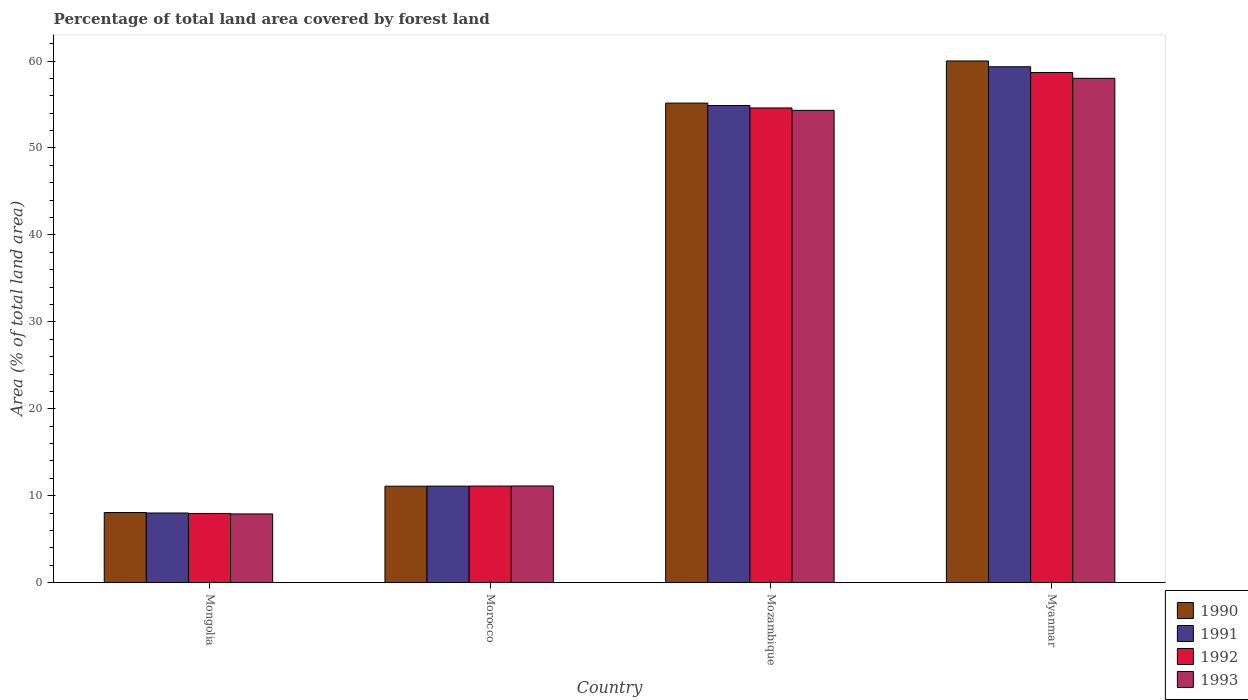How many groups of bars are there?
Offer a very short reply. 4. Are the number of bars on each tick of the X-axis equal?
Provide a succinct answer. Yes. How many bars are there on the 2nd tick from the left?
Provide a succinct answer. 4. What is the label of the 4th group of bars from the left?
Offer a terse response. Myanmar. In how many cases, is the number of bars for a given country not equal to the number of legend labels?
Ensure brevity in your answer.  0. What is the percentage of forest land in 1992 in Mongolia?
Your response must be concise. 7.96. Across all countries, what is the maximum percentage of forest land in 1990?
Keep it short and to the point. 60.01. Across all countries, what is the minimum percentage of forest land in 1993?
Offer a terse response. 7.91. In which country was the percentage of forest land in 1991 maximum?
Offer a very short reply. Myanmar. In which country was the percentage of forest land in 1991 minimum?
Make the answer very short. Mongolia. What is the total percentage of forest land in 1992 in the graph?
Your response must be concise. 132.36. What is the difference between the percentage of forest land in 1992 in Mozambique and that in Myanmar?
Offer a very short reply. -4.07. What is the difference between the percentage of forest land in 1993 in Mongolia and the percentage of forest land in 1990 in Mozambique?
Your response must be concise. -47.25. What is the average percentage of forest land in 1992 per country?
Your answer should be compact. 33.09. What is the difference between the percentage of forest land of/in 1990 and percentage of forest land of/in 1991 in Mongolia?
Provide a succinct answer. 0.05. In how many countries, is the percentage of forest land in 1990 greater than 34 %?
Offer a very short reply. 2. What is the ratio of the percentage of forest land in 1990 in Morocco to that in Mozambique?
Keep it short and to the point. 0.2. What is the difference between the highest and the second highest percentage of forest land in 1991?
Your response must be concise. -48.23. What is the difference between the highest and the lowest percentage of forest land in 1991?
Provide a succinct answer. 51.33. Is the sum of the percentage of forest land in 1991 in Mozambique and Myanmar greater than the maximum percentage of forest land in 1992 across all countries?
Keep it short and to the point. Yes. Is it the case that in every country, the sum of the percentage of forest land in 1992 and percentage of forest land in 1993 is greater than the sum of percentage of forest land in 1990 and percentage of forest land in 1991?
Ensure brevity in your answer.  No. What does the 1st bar from the left in Morocco represents?
Offer a terse response. 1990. What does the 3rd bar from the right in Morocco represents?
Ensure brevity in your answer.  1991. Are all the bars in the graph horizontal?
Make the answer very short. No. How many countries are there in the graph?
Provide a succinct answer. 4. What is the difference between two consecutive major ticks on the Y-axis?
Offer a very short reply. 10. Does the graph contain grids?
Ensure brevity in your answer.  No. What is the title of the graph?
Provide a short and direct response. Percentage of total land area covered by forest land. Does "1980" appear as one of the legend labels in the graph?
Your answer should be compact. No. What is the label or title of the X-axis?
Provide a short and direct response. Country. What is the label or title of the Y-axis?
Offer a very short reply. Area (% of total land area). What is the Area (% of total land area) in 1990 in Mongolia?
Give a very brief answer. 8.07. What is the Area (% of total land area) in 1991 in Mongolia?
Your answer should be compact. 8.02. What is the Area (% of total land area) of 1992 in Mongolia?
Offer a terse response. 7.96. What is the Area (% of total land area) in 1993 in Mongolia?
Provide a short and direct response. 7.91. What is the Area (% of total land area) in 1990 in Morocco?
Provide a short and direct response. 11.1. What is the Area (% of total land area) of 1991 in Morocco?
Offer a very short reply. 11.11. What is the Area (% of total land area) in 1992 in Morocco?
Offer a terse response. 11.12. What is the Area (% of total land area) of 1993 in Morocco?
Offer a terse response. 11.13. What is the Area (% of total land area) of 1990 in Mozambique?
Give a very brief answer. 55.16. What is the Area (% of total land area) in 1991 in Mozambique?
Offer a very short reply. 54.88. What is the Area (% of total land area) of 1992 in Mozambique?
Keep it short and to the point. 54.6. What is the Area (% of total land area) in 1993 in Mozambique?
Keep it short and to the point. 54.33. What is the Area (% of total land area) of 1990 in Myanmar?
Offer a terse response. 60.01. What is the Area (% of total land area) of 1991 in Myanmar?
Keep it short and to the point. 59.34. What is the Area (% of total land area) of 1992 in Myanmar?
Provide a short and direct response. 58.68. What is the Area (% of total land area) in 1993 in Myanmar?
Ensure brevity in your answer.  58.01. Across all countries, what is the maximum Area (% of total land area) in 1990?
Ensure brevity in your answer.  60.01. Across all countries, what is the maximum Area (% of total land area) in 1991?
Offer a terse response. 59.34. Across all countries, what is the maximum Area (% of total land area) of 1992?
Provide a succinct answer. 58.68. Across all countries, what is the maximum Area (% of total land area) of 1993?
Provide a short and direct response. 58.01. Across all countries, what is the minimum Area (% of total land area) in 1990?
Give a very brief answer. 8.07. Across all countries, what is the minimum Area (% of total land area) of 1991?
Give a very brief answer. 8.02. Across all countries, what is the minimum Area (% of total land area) of 1992?
Your response must be concise. 7.96. Across all countries, what is the minimum Area (% of total land area) of 1993?
Your response must be concise. 7.91. What is the total Area (% of total land area) in 1990 in the graph?
Provide a short and direct response. 134.34. What is the total Area (% of total land area) of 1991 in the graph?
Your answer should be compact. 133.35. What is the total Area (% of total land area) of 1992 in the graph?
Ensure brevity in your answer.  132.36. What is the total Area (% of total land area) of 1993 in the graph?
Your answer should be compact. 131.38. What is the difference between the Area (% of total land area) in 1990 in Mongolia and that in Morocco?
Offer a terse response. -3.03. What is the difference between the Area (% of total land area) of 1991 in Mongolia and that in Morocco?
Provide a succinct answer. -3.09. What is the difference between the Area (% of total land area) of 1992 in Mongolia and that in Morocco?
Offer a very short reply. -3.15. What is the difference between the Area (% of total land area) in 1993 in Mongolia and that in Morocco?
Offer a terse response. -3.22. What is the difference between the Area (% of total land area) in 1990 in Mongolia and that in Mozambique?
Keep it short and to the point. -47.09. What is the difference between the Area (% of total land area) of 1991 in Mongolia and that in Mozambique?
Your answer should be very brief. -46.87. What is the difference between the Area (% of total land area) in 1992 in Mongolia and that in Mozambique?
Offer a very short reply. -46.64. What is the difference between the Area (% of total land area) of 1993 in Mongolia and that in Mozambique?
Give a very brief answer. -46.42. What is the difference between the Area (% of total land area) of 1990 in Mongolia and that in Myanmar?
Your response must be concise. -51.94. What is the difference between the Area (% of total land area) in 1991 in Mongolia and that in Myanmar?
Your answer should be very brief. -51.33. What is the difference between the Area (% of total land area) in 1992 in Mongolia and that in Myanmar?
Keep it short and to the point. -50.71. What is the difference between the Area (% of total land area) in 1993 in Mongolia and that in Myanmar?
Your response must be concise. -50.1. What is the difference between the Area (% of total land area) in 1990 in Morocco and that in Mozambique?
Your answer should be very brief. -44.06. What is the difference between the Area (% of total land area) of 1991 in Morocco and that in Mozambique?
Provide a succinct answer. -43.77. What is the difference between the Area (% of total land area) of 1992 in Morocco and that in Mozambique?
Keep it short and to the point. -43.49. What is the difference between the Area (% of total land area) in 1993 in Morocco and that in Mozambique?
Provide a short and direct response. -43.2. What is the difference between the Area (% of total land area) of 1990 in Morocco and that in Myanmar?
Offer a terse response. -48.91. What is the difference between the Area (% of total land area) of 1991 in Morocco and that in Myanmar?
Keep it short and to the point. -48.23. What is the difference between the Area (% of total land area) of 1992 in Morocco and that in Myanmar?
Your response must be concise. -47.56. What is the difference between the Area (% of total land area) of 1993 in Morocco and that in Myanmar?
Ensure brevity in your answer.  -46.89. What is the difference between the Area (% of total land area) in 1990 in Mozambique and that in Myanmar?
Make the answer very short. -4.85. What is the difference between the Area (% of total land area) of 1991 in Mozambique and that in Myanmar?
Provide a succinct answer. -4.46. What is the difference between the Area (% of total land area) of 1992 in Mozambique and that in Myanmar?
Give a very brief answer. -4.07. What is the difference between the Area (% of total land area) in 1993 in Mozambique and that in Myanmar?
Ensure brevity in your answer.  -3.69. What is the difference between the Area (% of total land area) in 1990 in Mongolia and the Area (% of total land area) in 1991 in Morocco?
Provide a short and direct response. -3.04. What is the difference between the Area (% of total land area) in 1990 in Mongolia and the Area (% of total land area) in 1992 in Morocco?
Your response must be concise. -3.05. What is the difference between the Area (% of total land area) in 1990 in Mongolia and the Area (% of total land area) in 1993 in Morocco?
Provide a succinct answer. -3.06. What is the difference between the Area (% of total land area) of 1991 in Mongolia and the Area (% of total land area) of 1992 in Morocco?
Provide a short and direct response. -3.1. What is the difference between the Area (% of total land area) in 1991 in Mongolia and the Area (% of total land area) in 1993 in Morocco?
Offer a very short reply. -3.11. What is the difference between the Area (% of total land area) in 1992 in Mongolia and the Area (% of total land area) in 1993 in Morocco?
Your answer should be very brief. -3.16. What is the difference between the Area (% of total land area) in 1990 in Mongolia and the Area (% of total land area) in 1991 in Mozambique?
Make the answer very short. -46.81. What is the difference between the Area (% of total land area) in 1990 in Mongolia and the Area (% of total land area) in 1992 in Mozambique?
Give a very brief answer. -46.54. What is the difference between the Area (% of total land area) of 1990 in Mongolia and the Area (% of total land area) of 1993 in Mozambique?
Give a very brief answer. -46.26. What is the difference between the Area (% of total land area) of 1991 in Mongolia and the Area (% of total land area) of 1992 in Mozambique?
Offer a terse response. -46.59. What is the difference between the Area (% of total land area) of 1991 in Mongolia and the Area (% of total land area) of 1993 in Mozambique?
Your answer should be very brief. -46.31. What is the difference between the Area (% of total land area) of 1992 in Mongolia and the Area (% of total land area) of 1993 in Mozambique?
Ensure brevity in your answer.  -46.36. What is the difference between the Area (% of total land area) in 1990 in Mongolia and the Area (% of total land area) in 1991 in Myanmar?
Provide a short and direct response. -51.27. What is the difference between the Area (% of total land area) of 1990 in Mongolia and the Area (% of total land area) of 1992 in Myanmar?
Your response must be concise. -50.61. What is the difference between the Area (% of total land area) of 1990 in Mongolia and the Area (% of total land area) of 1993 in Myanmar?
Your answer should be very brief. -49.94. What is the difference between the Area (% of total land area) in 1991 in Mongolia and the Area (% of total land area) in 1992 in Myanmar?
Your answer should be compact. -50.66. What is the difference between the Area (% of total land area) of 1991 in Mongolia and the Area (% of total land area) of 1993 in Myanmar?
Provide a short and direct response. -50. What is the difference between the Area (% of total land area) of 1992 in Mongolia and the Area (% of total land area) of 1993 in Myanmar?
Your answer should be very brief. -50.05. What is the difference between the Area (% of total land area) of 1990 in Morocco and the Area (% of total land area) of 1991 in Mozambique?
Ensure brevity in your answer.  -43.78. What is the difference between the Area (% of total land area) of 1990 in Morocco and the Area (% of total land area) of 1992 in Mozambique?
Offer a very short reply. -43.5. What is the difference between the Area (% of total land area) of 1990 in Morocco and the Area (% of total land area) of 1993 in Mozambique?
Your answer should be very brief. -43.23. What is the difference between the Area (% of total land area) in 1991 in Morocco and the Area (% of total land area) in 1992 in Mozambique?
Your response must be concise. -43.5. What is the difference between the Area (% of total land area) of 1991 in Morocco and the Area (% of total land area) of 1993 in Mozambique?
Make the answer very short. -43.22. What is the difference between the Area (% of total land area) of 1992 in Morocco and the Area (% of total land area) of 1993 in Mozambique?
Keep it short and to the point. -43.21. What is the difference between the Area (% of total land area) in 1990 in Morocco and the Area (% of total land area) in 1991 in Myanmar?
Make the answer very short. -48.24. What is the difference between the Area (% of total land area) in 1990 in Morocco and the Area (% of total land area) in 1992 in Myanmar?
Offer a very short reply. -47.58. What is the difference between the Area (% of total land area) of 1990 in Morocco and the Area (% of total land area) of 1993 in Myanmar?
Offer a terse response. -46.91. What is the difference between the Area (% of total land area) in 1991 in Morocco and the Area (% of total land area) in 1992 in Myanmar?
Keep it short and to the point. -47.57. What is the difference between the Area (% of total land area) of 1991 in Morocco and the Area (% of total land area) of 1993 in Myanmar?
Make the answer very short. -46.9. What is the difference between the Area (% of total land area) of 1992 in Morocco and the Area (% of total land area) of 1993 in Myanmar?
Your answer should be very brief. -46.89. What is the difference between the Area (% of total land area) in 1990 in Mozambique and the Area (% of total land area) in 1991 in Myanmar?
Make the answer very short. -4.18. What is the difference between the Area (% of total land area) of 1990 in Mozambique and the Area (% of total land area) of 1992 in Myanmar?
Provide a succinct answer. -3.52. What is the difference between the Area (% of total land area) in 1990 in Mozambique and the Area (% of total land area) in 1993 in Myanmar?
Give a very brief answer. -2.85. What is the difference between the Area (% of total land area) of 1991 in Mozambique and the Area (% of total land area) of 1992 in Myanmar?
Offer a terse response. -3.79. What is the difference between the Area (% of total land area) in 1991 in Mozambique and the Area (% of total land area) in 1993 in Myanmar?
Provide a succinct answer. -3.13. What is the difference between the Area (% of total land area) in 1992 in Mozambique and the Area (% of total land area) in 1993 in Myanmar?
Ensure brevity in your answer.  -3.41. What is the average Area (% of total land area) in 1990 per country?
Provide a short and direct response. 33.58. What is the average Area (% of total land area) of 1991 per country?
Provide a succinct answer. 33.34. What is the average Area (% of total land area) in 1992 per country?
Your answer should be compact. 33.09. What is the average Area (% of total land area) in 1993 per country?
Your answer should be compact. 32.84. What is the difference between the Area (% of total land area) in 1990 and Area (% of total land area) in 1991 in Mongolia?
Offer a terse response. 0.05. What is the difference between the Area (% of total land area) in 1990 and Area (% of total land area) in 1992 in Mongolia?
Keep it short and to the point. 0.11. What is the difference between the Area (% of total land area) of 1990 and Area (% of total land area) of 1993 in Mongolia?
Provide a succinct answer. 0.16. What is the difference between the Area (% of total land area) of 1991 and Area (% of total land area) of 1992 in Mongolia?
Ensure brevity in your answer.  0.05. What is the difference between the Area (% of total land area) of 1991 and Area (% of total land area) of 1993 in Mongolia?
Offer a very short reply. 0.11. What is the difference between the Area (% of total land area) of 1992 and Area (% of total land area) of 1993 in Mongolia?
Your answer should be very brief. 0.05. What is the difference between the Area (% of total land area) of 1990 and Area (% of total land area) of 1991 in Morocco?
Make the answer very short. -0.01. What is the difference between the Area (% of total land area) in 1990 and Area (% of total land area) in 1992 in Morocco?
Make the answer very short. -0.02. What is the difference between the Area (% of total land area) of 1990 and Area (% of total land area) of 1993 in Morocco?
Give a very brief answer. -0.03. What is the difference between the Area (% of total land area) in 1991 and Area (% of total land area) in 1992 in Morocco?
Your answer should be very brief. -0.01. What is the difference between the Area (% of total land area) of 1991 and Area (% of total land area) of 1993 in Morocco?
Make the answer very short. -0.02. What is the difference between the Area (% of total land area) in 1992 and Area (% of total land area) in 1993 in Morocco?
Your response must be concise. -0.01. What is the difference between the Area (% of total land area) in 1990 and Area (% of total land area) in 1991 in Mozambique?
Provide a succinct answer. 0.28. What is the difference between the Area (% of total land area) in 1990 and Area (% of total land area) in 1992 in Mozambique?
Provide a short and direct response. 0.56. What is the difference between the Area (% of total land area) in 1990 and Area (% of total land area) in 1993 in Mozambique?
Your response must be concise. 0.84. What is the difference between the Area (% of total land area) in 1991 and Area (% of total land area) in 1992 in Mozambique?
Offer a very short reply. 0.28. What is the difference between the Area (% of total land area) of 1991 and Area (% of total land area) of 1993 in Mozambique?
Offer a terse response. 0.56. What is the difference between the Area (% of total land area) in 1992 and Area (% of total land area) in 1993 in Mozambique?
Your response must be concise. 0.28. What is the difference between the Area (% of total land area) in 1990 and Area (% of total land area) in 1991 in Myanmar?
Your response must be concise. 0.67. What is the difference between the Area (% of total land area) of 1990 and Area (% of total land area) of 1992 in Myanmar?
Make the answer very short. 1.33. What is the difference between the Area (% of total land area) of 1990 and Area (% of total land area) of 1993 in Myanmar?
Give a very brief answer. 2. What is the difference between the Area (% of total land area) of 1991 and Area (% of total land area) of 1992 in Myanmar?
Give a very brief answer. 0.67. What is the difference between the Area (% of total land area) of 1991 and Area (% of total land area) of 1993 in Myanmar?
Your answer should be very brief. 1.33. What is the difference between the Area (% of total land area) in 1992 and Area (% of total land area) in 1993 in Myanmar?
Offer a very short reply. 0.67. What is the ratio of the Area (% of total land area) of 1990 in Mongolia to that in Morocco?
Provide a short and direct response. 0.73. What is the ratio of the Area (% of total land area) of 1991 in Mongolia to that in Morocco?
Keep it short and to the point. 0.72. What is the ratio of the Area (% of total land area) of 1992 in Mongolia to that in Morocco?
Your answer should be very brief. 0.72. What is the ratio of the Area (% of total land area) in 1993 in Mongolia to that in Morocco?
Offer a very short reply. 0.71. What is the ratio of the Area (% of total land area) in 1990 in Mongolia to that in Mozambique?
Ensure brevity in your answer.  0.15. What is the ratio of the Area (% of total land area) in 1991 in Mongolia to that in Mozambique?
Make the answer very short. 0.15. What is the ratio of the Area (% of total land area) in 1992 in Mongolia to that in Mozambique?
Provide a short and direct response. 0.15. What is the ratio of the Area (% of total land area) in 1993 in Mongolia to that in Mozambique?
Your answer should be very brief. 0.15. What is the ratio of the Area (% of total land area) in 1990 in Mongolia to that in Myanmar?
Keep it short and to the point. 0.13. What is the ratio of the Area (% of total land area) in 1991 in Mongolia to that in Myanmar?
Your response must be concise. 0.14. What is the ratio of the Area (% of total land area) of 1992 in Mongolia to that in Myanmar?
Offer a very short reply. 0.14. What is the ratio of the Area (% of total land area) in 1993 in Mongolia to that in Myanmar?
Offer a terse response. 0.14. What is the ratio of the Area (% of total land area) in 1990 in Morocco to that in Mozambique?
Your response must be concise. 0.2. What is the ratio of the Area (% of total land area) of 1991 in Morocco to that in Mozambique?
Keep it short and to the point. 0.2. What is the ratio of the Area (% of total land area) in 1992 in Morocco to that in Mozambique?
Your answer should be compact. 0.2. What is the ratio of the Area (% of total land area) of 1993 in Morocco to that in Mozambique?
Your response must be concise. 0.2. What is the ratio of the Area (% of total land area) in 1990 in Morocco to that in Myanmar?
Provide a short and direct response. 0.18. What is the ratio of the Area (% of total land area) in 1991 in Morocco to that in Myanmar?
Offer a very short reply. 0.19. What is the ratio of the Area (% of total land area) of 1992 in Morocco to that in Myanmar?
Your answer should be very brief. 0.19. What is the ratio of the Area (% of total land area) of 1993 in Morocco to that in Myanmar?
Keep it short and to the point. 0.19. What is the ratio of the Area (% of total land area) of 1990 in Mozambique to that in Myanmar?
Give a very brief answer. 0.92. What is the ratio of the Area (% of total land area) of 1991 in Mozambique to that in Myanmar?
Your answer should be very brief. 0.92. What is the ratio of the Area (% of total land area) in 1992 in Mozambique to that in Myanmar?
Make the answer very short. 0.93. What is the ratio of the Area (% of total land area) in 1993 in Mozambique to that in Myanmar?
Provide a short and direct response. 0.94. What is the difference between the highest and the second highest Area (% of total land area) in 1990?
Provide a succinct answer. 4.85. What is the difference between the highest and the second highest Area (% of total land area) of 1991?
Your answer should be compact. 4.46. What is the difference between the highest and the second highest Area (% of total land area) in 1992?
Give a very brief answer. 4.07. What is the difference between the highest and the second highest Area (% of total land area) in 1993?
Offer a terse response. 3.69. What is the difference between the highest and the lowest Area (% of total land area) in 1990?
Your response must be concise. 51.94. What is the difference between the highest and the lowest Area (% of total land area) of 1991?
Keep it short and to the point. 51.33. What is the difference between the highest and the lowest Area (% of total land area) of 1992?
Offer a very short reply. 50.71. What is the difference between the highest and the lowest Area (% of total land area) of 1993?
Keep it short and to the point. 50.1. 